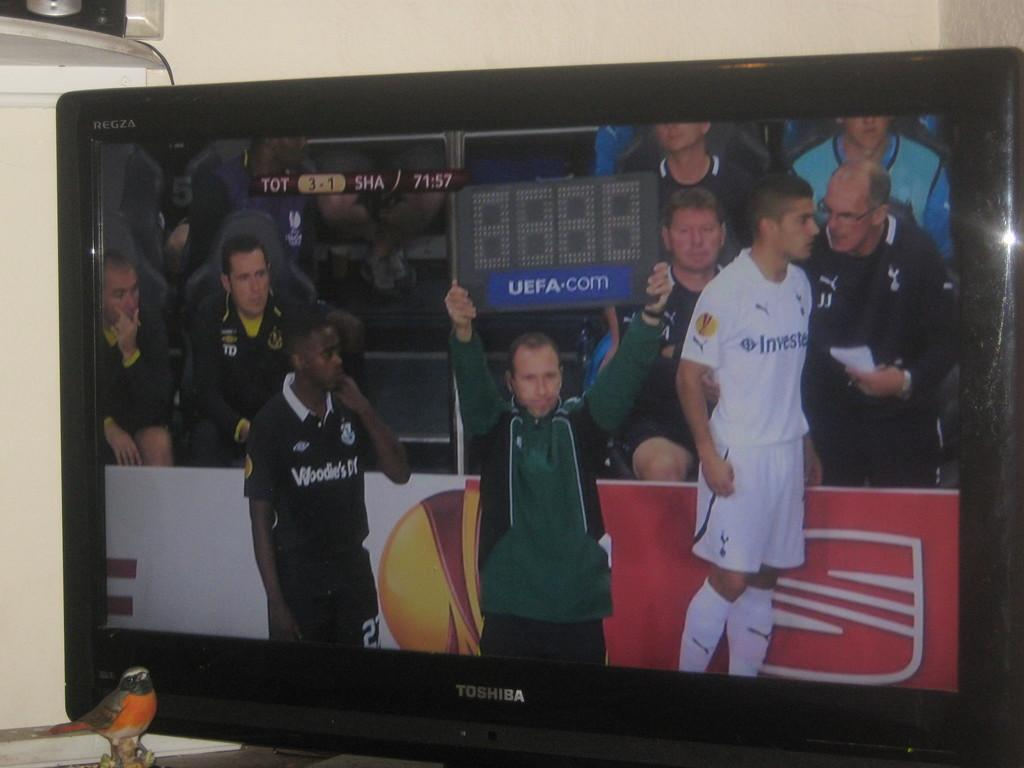Provide a one-sentence caption for the provided image. A man is holding up a blank scoreboard that also reads UEFA.com. 